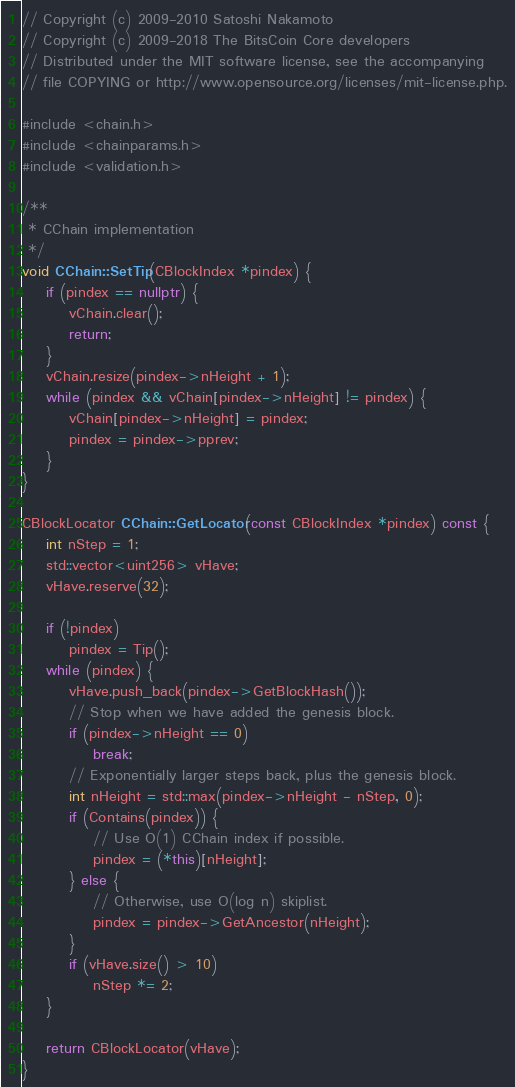Convert code to text. <code><loc_0><loc_0><loc_500><loc_500><_C++_>// Copyright (c) 2009-2010 Satoshi Nakamoto
// Copyright (c) 2009-2018 The BitsCoin Core developers
// Distributed under the MIT software license, see the accompanying
// file COPYING or http://www.opensource.org/licenses/mit-license.php.

#include <chain.h>
#include <chainparams.h>
#include <validation.h>

/**
 * CChain implementation
 */
void CChain::SetTip(CBlockIndex *pindex) {
    if (pindex == nullptr) {
        vChain.clear();
        return;
    }
    vChain.resize(pindex->nHeight + 1);
    while (pindex && vChain[pindex->nHeight] != pindex) {
        vChain[pindex->nHeight] = pindex;
        pindex = pindex->pprev;
    }
}

CBlockLocator CChain::GetLocator(const CBlockIndex *pindex) const {
    int nStep = 1;
    std::vector<uint256> vHave;
    vHave.reserve(32);

    if (!pindex)
        pindex = Tip();
    while (pindex) {
        vHave.push_back(pindex->GetBlockHash());
        // Stop when we have added the genesis block.
        if (pindex->nHeight == 0)
            break;
        // Exponentially larger steps back, plus the genesis block.
        int nHeight = std::max(pindex->nHeight - nStep, 0);
        if (Contains(pindex)) {
            // Use O(1) CChain index if possible.
            pindex = (*this)[nHeight];
        } else {
            // Otherwise, use O(log n) skiplist.
            pindex = pindex->GetAncestor(nHeight);
        }
        if (vHave.size() > 10)
            nStep *= 2;
    }

    return CBlockLocator(vHave);
}
</code> 